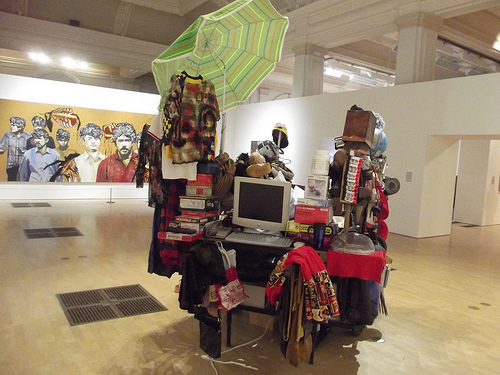<image>
Is the umbrella above the shirt? Yes. The umbrella is positioned above the shirt in the vertical space, higher up in the scene. 